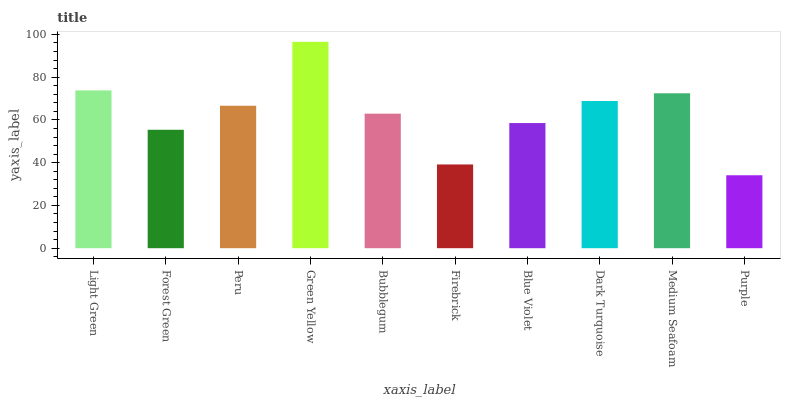Is Purple the minimum?
Answer yes or no. Yes. Is Green Yellow the maximum?
Answer yes or no. Yes. Is Forest Green the minimum?
Answer yes or no. No. Is Forest Green the maximum?
Answer yes or no. No. Is Light Green greater than Forest Green?
Answer yes or no. Yes. Is Forest Green less than Light Green?
Answer yes or no. Yes. Is Forest Green greater than Light Green?
Answer yes or no. No. Is Light Green less than Forest Green?
Answer yes or no. No. Is Peru the high median?
Answer yes or no. Yes. Is Bubblegum the low median?
Answer yes or no. Yes. Is Forest Green the high median?
Answer yes or no. No. Is Green Yellow the low median?
Answer yes or no. No. 